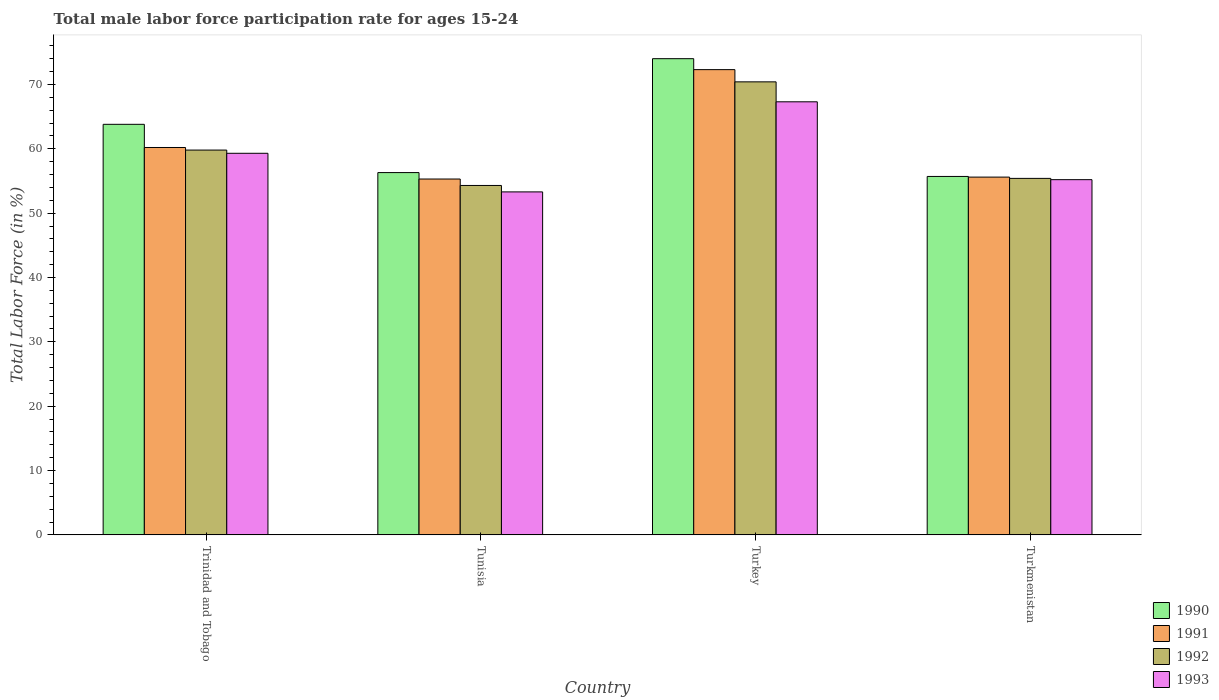How many different coloured bars are there?
Give a very brief answer. 4. How many groups of bars are there?
Your response must be concise. 4. How many bars are there on the 1st tick from the left?
Provide a short and direct response. 4. What is the male labor force participation rate in 1992 in Turkey?
Give a very brief answer. 70.4. Across all countries, what is the maximum male labor force participation rate in 1993?
Keep it short and to the point. 67.3. Across all countries, what is the minimum male labor force participation rate in 1990?
Keep it short and to the point. 55.7. In which country was the male labor force participation rate in 1992 maximum?
Provide a succinct answer. Turkey. In which country was the male labor force participation rate in 1991 minimum?
Give a very brief answer. Tunisia. What is the total male labor force participation rate in 1993 in the graph?
Keep it short and to the point. 235.1. What is the difference between the male labor force participation rate in 1991 in Trinidad and Tobago and that in Turkmenistan?
Your response must be concise. 4.6. What is the difference between the male labor force participation rate in 1993 in Trinidad and Tobago and the male labor force participation rate in 1990 in Turkey?
Give a very brief answer. -14.7. What is the average male labor force participation rate in 1992 per country?
Your answer should be compact. 59.98. What is the difference between the male labor force participation rate of/in 1993 and male labor force participation rate of/in 1991 in Turkmenistan?
Keep it short and to the point. -0.4. What is the ratio of the male labor force participation rate in 1992 in Trinidad and Tobago to that in Tunisia?
Your response must be concise. 1.1. What is the difference between the highest and the second highest male labor force participation rate in 1990?
Keep it short and to the point. -17.7. What is the difference between the highest and the lowest male labor force participation rate in 1993?
Your answer should be very brief. 14. In how many countries, is the male labor force participation rate in 1990 greater than the average male labor force participation rate in 1990 taken over all countries?
Offer a terse response. 2. What does the 1st bar from the right in Tunisia represents?
Ensure brevity in your answer.  1993. How many bars are there?
Offer a very short reply. 16. Are all the bars in the graph horizontal?
Your response must be concise. No. What is the difference between two consecutive major ticks on the Y-axis?
Your answer should be very brief. 10. Does the graph contain any zero values?
Offer a terse response. No. Does the graph contain grids?
Make the answer very short. No. How are the legend labels stacked?
Provide a short and direct response. Vertical. What is the title of the graph?
Provide a short and direct response. Total male labor force participation rate for ages 15-24. Does "1992" appear as one of the legend labels in the graph?
Ensure brevity in your answer.  Yes. What is the label or title of the Y-axis?
Offer a very short reply. Total Labor Force (in %). What is the Total Labor Force (in %) of 1990 in Trinidad and Tobago?
Offer a terse response. 63.8. What is the Total Labor Force (in %) in 1991 in Trinidad and Tobago?
Provide a short and direct response. 60.2. What is the Total Labor Force (in %) in 1992 in Trinidad and Tobago?
Provide a short and direct response. 59.8. What is the Total Labor Force (in %) of 1993 in Trinidad and Tobago?
Make the answer very short. 59.3. What is the Total Labor Force (in %) of 1990 in Tunisia?
Provide a short and direct response. 56.3. What is the Total Labor Force (in %) of 1991 in Tunisia?
Keep it short and to the point. 55.3. What is the Total Labor Force (in %) of 1992 in Tunisia?
Keep it short and to the point. 54.3. What is the Total Labor Force (in %) in 1993 in Tunisia?
Your response must be concise. 53.3. What is the Total Labor Force (in %) in 1990 in Turkey?
Your answer should be compact. 74. What is the Total Labor Force (in %) of 1991 in Turkey?
Offer a very short reply. 72.3. What is the Total Labor Force (in %) of 1992 in Turkey?
Provide a succinct answer. 70.4. What is the Total Labor Force (in %) of 1993 in Turkey?
Make the answer very short. 67.3. What is the Total Labor Force (in %) of 1990 in Turkmenistan?
Your answer should be very brief. 55.7. What is the Total Labor Force (in %) in 1991 in Turkmenistan?
Ensure brevity in your answer.  55.6. What is the Total Labor Force (in %) of 1992 in Turkmenistan?
Keep it short and to the point. 55.4. What is the Total Labor Force (in %) in 1993 in Turkmenistan?
Provide a short and direct response. 55.2. Across all countries, what is the maximum Total Labor Force (in %) of 1991?
Provide a succinct answer. 72.3. Across all countries, what is the maximum Total Labor Force (in %) of 1992?
Your answer should be compact. 70.4. Across all countries, what is the maximum Total Labor Force (in %) of 1993?
Your answer should be compact. 67.3. Across all countries, what is the minimum Total Labor Force (in %) in 1990?
Offer a terse response. 55.7. Across all countries, what is the minimum Total Labor Force (in %) of 1991?
Make the answer very short. 55.3. Across all countries, what is the minimum Total Labor Force (in %) in 1992?
Make the answer very short. 54.3. Across all countries, what is the minimum Total Labor Force (in %) of 1993?
Keep it short and to the point. 53.3. What is the total Total Labor Force (in %) of 1990 in the graph?
Make the answer very short. 249.8. What is the total Total Labor Force (in %) in 1991 in the graph?
Offer a terse response. 243.4. What is the total Total Labor Force (in %) of 1992 in the graph?
Your answer should be compact. 239.9. What is the total Total Labor Force (in %) of 1993 in the graph?
Give a very brief answer. 235.1. What is the difference between the Total Labor Force (in %) in 1990 in Trinidad and Tobago and that in Tunisia?
Your answer should be very brief. 7.5. What is the difference between the Total Labor Force (in %) of 1991 in Trinidad and Tobago and that in Tunisia?
Make the answer very short. 4.9. What is the difference between the Total Labor Force (in %) of 1992 in Trinidad and Tobago and that in Tunisia?
Provide a short and direct response. 5.5. What is the difference between the Total Labor Force (in %) in 1990 in Trinidad and Tobago and that in Turkey?
Make the answer very short. -10.2. What is the difference between the Total Labor Force (in %) in 1993 in Trinidad and Tobago and that in Turkey?
Offer a terse response. -8. What is the difference between the Total Labor Force (in %) in 1990 in Trinidad and Tobago and that in Turkmenistan?
Your answer should be very brief. 8.1. What is the difference between the Total Labor Force (in %) of 1993 in Trinidad and Tobago and that in Turkmenistan?
Your answer should be very brief. 4.1. What is the difference between the Total Labor Force (in %) of 1990 in Tunisia and that in Turkey?
Keep it short and to the point. -17.7. What is the difference between the Total Labor Force (in %) in 1992 in Tunisia and that in Turkey?
Provide a short and direct response. -16.1. What is the difference between the Total Labor Force (in %) in 1993 in Tunisia and that in Turkey?
Provide a succinct answer. -14. What is the difference between the Total Labor Force (in %) of 1993 in Tunisia and that in Turkmenistan?
Your answer should be compact. -1.9. What is the difference between the Total Labor Force (in %) of 1991 in Turkey and that in Turkmenistan?
Keep it short and to the point. 16.7. What is the difference between the Total Labor Force (in %) in 1990 in Trinidad and Tobago and the Total Labor Force (in %) in 1991 in Turkey?
Ensure brevity in your answer.  -8.5. What is the difference between the Total Labor Force (in %) in 1990 in Trinidad and Tobago and the Total Labor Force (in %) in 1992 in Turkey?
Your answer should be very brief. -6.6. What is the difference between the Total Labor Force (in %) of 1991 in Trinidad and Tobago and the Total Labor Force (in %) of 1993 in Turkey?
Offer a terse response. -7.1. What is the difference between the Total Labor Force (in %) of 1990 in Trinidad and Tobago and the Total Labor Force (in %) of 1991 in Turkmenistan?
Your response must be concise. 8.2. What is the difference between the Total Labor Force (in %) in 1990 in Trinidad and Tobago and the Total Labor Force (in %) in 1993 in Turkmenistan?
Provide a succinct answer. 8.6. What is the difference between the Total Labor Force (in %) of 1991 in Trinidad and Tobago and the Total Labor Force (in %) of 1993 in Turkmenistan?
Provide a short and direct response. 5. What is the difference between the Total Labor Force (in %) of 1990 in Tunisia and the Total Labor Force (in %) of 1992 in Turkey?
Provide a short and direct response. -14.1. What is the difference between the Total Labor Force (in %) in 1990 in Tunisia and the Total Labor Force (in %) in 1993 in Turkey?
Ensure brevity in your answer.  -11. What is the difference between the Total Labor Force (in %) in 1991 in Tunisia and the Total Labor Force (in %) in 1992 in Turkey?
Offer a terse response. -15.1. What is the difference between the Total Labor Force (in %) of 1991 in Tunisia and the Total Labor Force (in %) of 1993 in Turkey?
Your answer should be very brief. -12. What is the difference between the Total Labor Force (in %) in 1992 in Tunisia and the Total Labor Force (in %) in 1993 in Turkey?
Your answer should be very brief. -13. What is the difference between the Total Labor Force (in %) of 1990 in Tunisia and the Total Labor Force (in %) of 1991 in Turkmenistan?
Keep it short and to the point. 0.7. What is the difference between the Total Labor Force (in %) in 1990 in Tunisia and the Total Labor Force (in %) in 1992 in Turkmenistan?
Keep it short and to the point. 0.9. What is the difference between the Total Labor Force (in %) in 1990 in Turkey and the Total Labor Force (in %) in 1993 in Turkmenistan?
Ensure brevity in your answer.  18.8. What is the average Total Labor Force (in %) in 1990 per country?
Offer a very short reply. 62.45. What is the average Total Labor Force (in %) in 1991 per country?
Ensure brevity in your answer.  60.85. What is the average Total Labor Force (in %) in 1992 per country?
Your answer should be very brief. 59.98. What is the average Total Labor Force (in %) in 1993 per country?
Offer a terse response. 58.77. What is the difference between the Total Labor Force (in %) in 1990 and Total Labor Force (in %) in 1991 in Trinidad and Tobago?
Your answer should be compact. 3.6. What is the difference between the Total Labor Force (in %) in 1990 and Total Labor Force (in %) in 1993 in Trinidad and Tobago?
Your response must be concise. 4.5. What is the difference between the Total Labor Force (in %) of 1992 and Total Labor Force (in %) of 1993 in Trinidad and Tobago?
Ensure brevity in your answer.  0.5. What is the difference between the Total Labor Force (in %) in 1990 and Total Labor Force (in %) in 1992 in Tunisia?
Your answer should be compact. 2. What is the difference between the Total Labor Force (in %) of 1991 and Total Labor Force (in %) of 1992 in Tunisia?
Give a very brief answer. 1. What is the difference between the Total Labor Force (in %) of 1990 and Total Labor Force (in %) of 1993 in Turkey?
Your answer should be very brief. 6.7. What is the difference between the Total Labor Force (in %) of 1992 and Total Labor Force (in %) of 1993 in Turkey?
Your answer should be very brief. 3.1. What is the difference between the Total Labor Force (in %) of 1990 and Total Labor Force (in %) of 1992 in Turkmenistan?
Provide a succinct answer. 0.3. What is the difference between the Total Labor Force (in %) of 1991 and Total Labor Force (in %) of 1992 in Turkmenistan?
Offer a very short reply. 0.2. What is the ratio of the Total Labor Force (in %) in 1990 in Trinidad and Tobago to that in Tunisia?
Give a very brief answer. 1.13. What is the ratio of the Total Labor Force (in %) of 1991 in Trinidad and Tobago to that in Tunisia?
Ensure brevity in your answer.  1.09. What is the ratio of the Total Labor Force (in %) in 1992 in Trinidad and Tobago to that in Tunisia?
Your answer should be compact. 1.1. What is the ratio of the Total Labor Force (in %) of 1993 in Trinidad and Tobago to that in Tunisia?
Make the answer very short. 1.11. What is the ratio of the Total Labor Force (in %) in 1990 in Trinidad and Tobago to that in Turkey?
Provide a short and direct response. 0.86. What is the ratio of the Total Labor Force (in %) in 1991 in Trinidad and Tobago to that in Turkey?
Offer a very short reply. 0.83. What is the ratio of the Total Labor Force (in %) of 1992 in Trinidad and Tobago to that in Turkey?
Offer a very short reply. 0.85. What is the ratio of the Total Labor Force (in %) in 1993 in Trinidad and Tobago to that in Turkey?
Offer a very short reply. 0.88. What is the ratio of the Total Labor Force (in %) in 1990 in Trinidad and Tobago to that in Turkmenistan?
Your answer should be compact. 1.15. What is the ratio of the Total Labor Force (in %) in 1991 in Trinidad and Tobago to that in Turkmenistan?
Keep it short and to the point. 1.08. What is the ratio of the Total Labor Force (in %) in 1992 in Trinidad and Tobago to that in Turkmenistan?
Ensure brevity in your answer.  1.08. What is the ratio of the Total Labor Force (in %) of 1993 in Trinidad and Tobago to that in Turkmenistan?
Your response must be concise. 1.07. What is the ratio of the Total Labor Force (in %) in 1990 in Tunisia to that in Turkey?
Make the answer very short. 0.76. What is the ratio of the Total Labor Force (in %) in 1991 in Tunisia to that in Turkey?
Give a very brief answer. 0.76. What is the ratio of the Total Labor Force (in %) in 1992 in Tunisia to that in Turkey?
Offer a terse response. 0.77. What is the ratio of the Total Labor Force (in %) in 1993 in Tunisia to that in Turkey?
Offer a very short reply. 0.79. What is the ratio of the Total Labor Force (in %) in 1990 in Tunisia to that in Turkmenistan?
Provide a succinct answer. 1.01. What is the ratio of the Total Labor Force (in %) in 1992 in Tunisia to that in Turkmenistan?
Offer a terse response. 0.98. What is the ratio of the Total Labor Force (in %) of 1993 in Tunisia to that in Turkmenistan?
Make the answer very short. 0.97. What is the ratio of the Total Labor Force (in %) in 1990 in Turkey to that in Turkmenistan?
Ensure brevity in your answer.  1.33. What is the ratio of the Total Labor Force (in %) in 1991 in Turkey to that in Turkmenistan?
Offer a terse response. 1.3. What is the ratio of the Total Labor Force (in %) in 1992 in Turkey to that in Turkmenistan?
Offer a very short reply. 1.27. What is the ratio of the Total Labor Force (in %) of 1993 in Turkey to that in Turkmenistan?
Your response must be concise. 1.22. What is the difference between the highest and the second highest Total Labor Force (in %) in 1991?
Give a very brief answer. 12.1. What is the difference between the highest and the second highest Total Labor Force (in %) of 1992?
Provide a succinct answer. 10.6. What is the difference between the highest and the second highest Total Labor Force (in %) in 1993?
Provide a succinct answer. 8. What is the difference between the highest and the lowest Total Labor Force (in %) of 1990?
Ensure brevity in your answer.  18.3. 